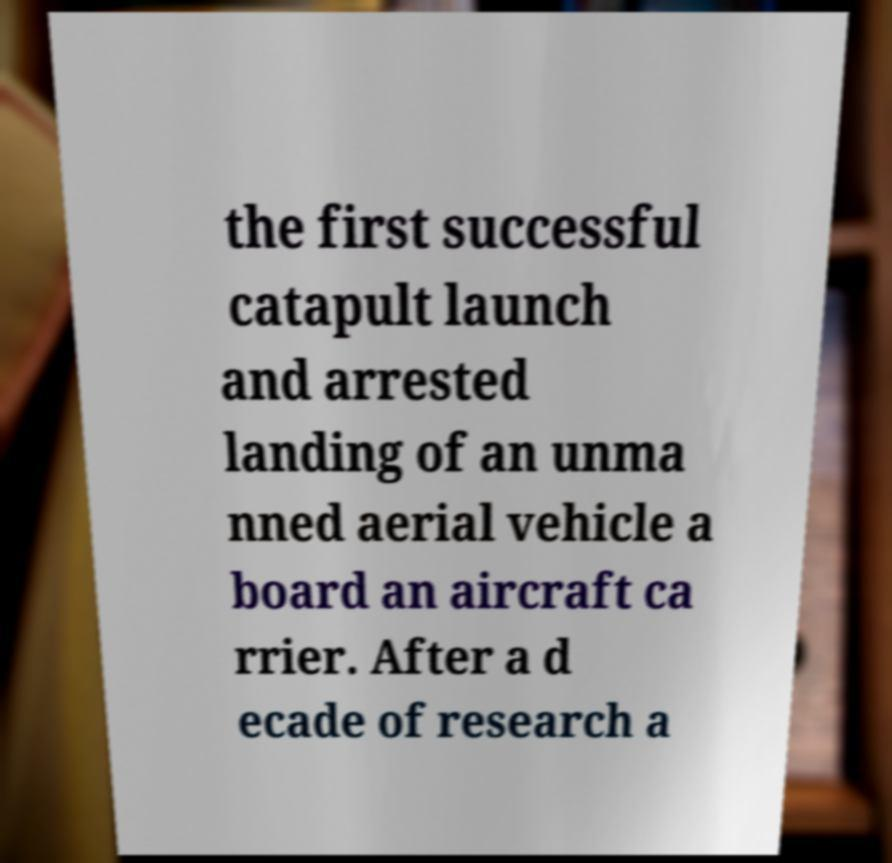For documentation purposes, I need the text within this image transcribed. Could you provide that? the first successful catapult launch and arrested landing of an unma nned aerial vehicle a board an aircraft ca rrier. After a d ecade of research a 